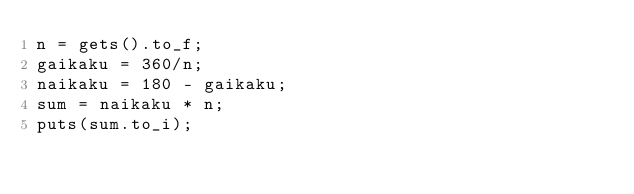<code> <loc_0><loc_0><loc_500><loc_500><_Ruby_>n = gets().to_f;
gaikaku = 360/n;
naikaku = 180 - gaikaku;
sum = naikaku * n;
puts(sum.to_i);</code> 